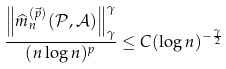Convert formula to latex. <formula><loc_0><loc_0><loc_500><loc_500>\frac { \left \| \widehat { m } _ { n } ^ { ( \vec { p } ) } ( \mathcal { P } , \mathcal { A } ) \right \| _ { \gamma } ^ { \gamma } } { ( n \log n ) ^ { p } } \leq C ( \log n ) ^ { - \frac { \gamma } { 2 } }</formula> 